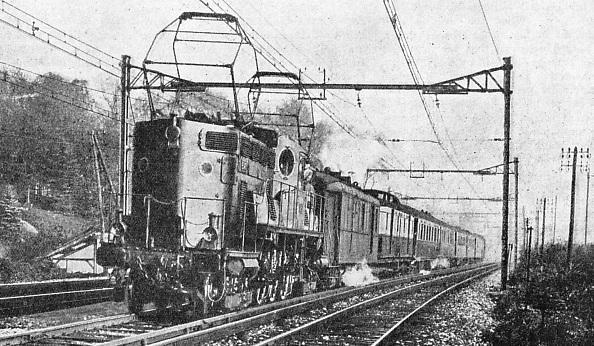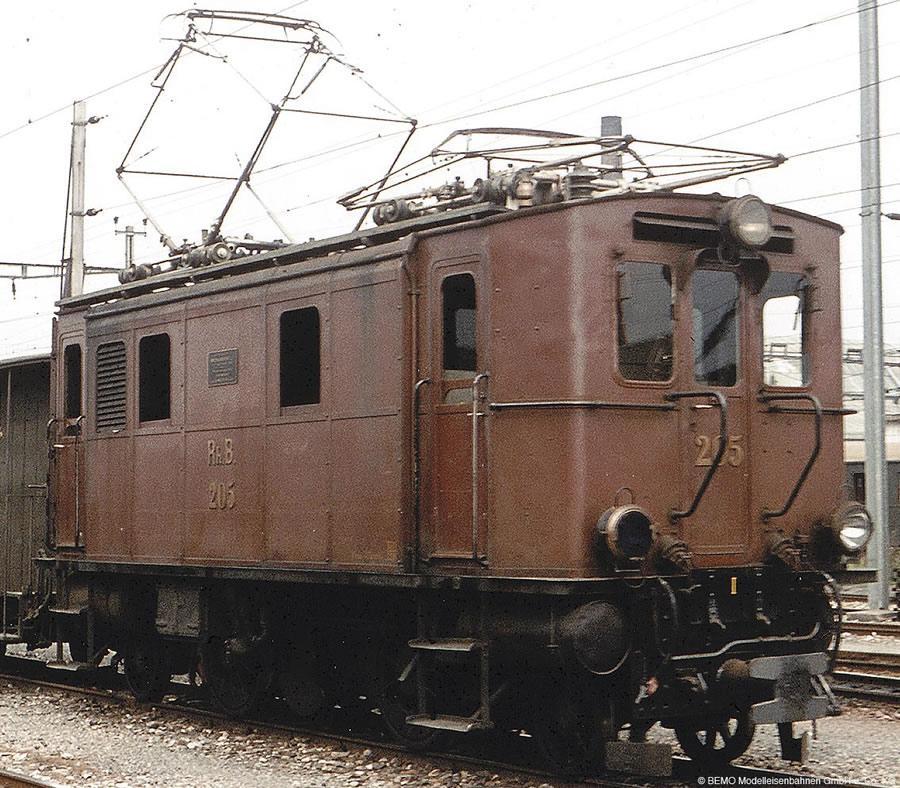The first image is the image on the left, the second image is the image on the right. For the images displayed, is the sentence "The two trains pictured head in opposite directions, and the train on the right has three windows across the front." factually correct? Answer yes or no. Yes. The first image is the image on the left, the second image is the image on the right. For the images shown, is this caption "There are two trains facing opposite directions, in black and white." true? Answer yes or no. No. 